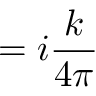Convert formula to latex. <formula><loc_0><loc_0><loc_500><loc_500>= i { \frac { k } { 4 \pi } }</formula> 